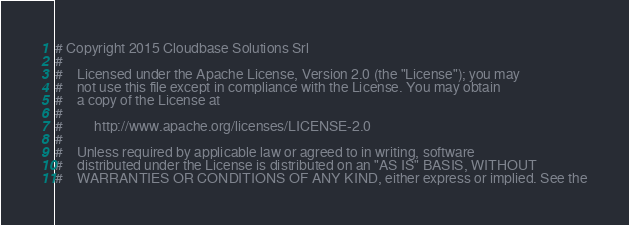Convert code to text. <code><loc_0><loc_0><loc_500><loc_500><_Python_># Copyright 2015 Cloudbase Solutions Srl
#
#    Licensed under the Apache License, Version 2.0 (the "License"); you may
#    not use this file except in compliance with the License. You may obtain
#    a copy of the License at
#
#         http://www.apache.org/licenses/LICENSE-2.0
#
#    Unless required by applicable law or agreed to in writing, software
#    distributed under the License is distributed on an "AS IS" BASIS, WITHOUT
#    WARRANTIES OR CONDITIONS OF ANY KIND, either express or implied. See the</code> 